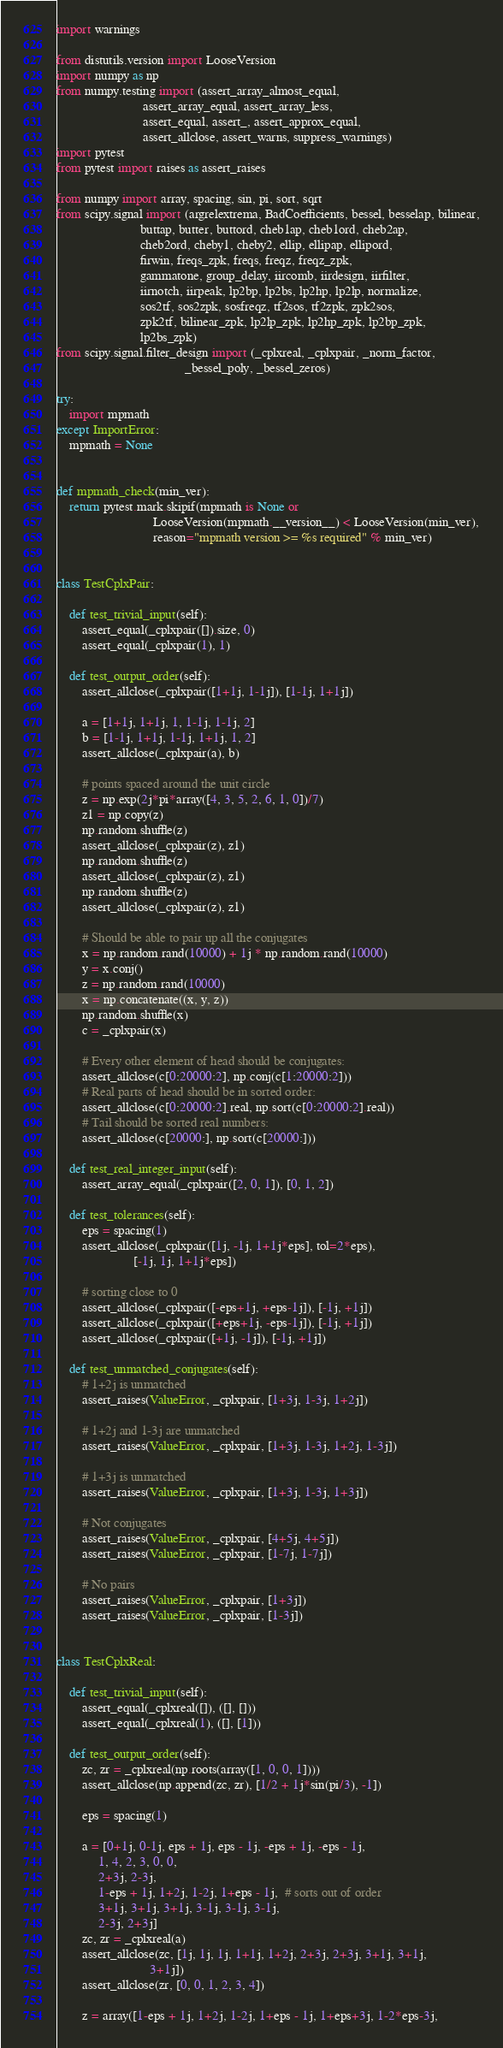<code> <loc_0><loc_0><loc_500><loc_500><_Python_>import warnings

from distutils.version import LooseVersion
import numpy as np
from numpy.testing import (assert_array_almost_equal,
                           assert_array_equal, assert_array_less,
                           assert_equal, assert_, assert_approx_equal,
                           assert_allclose, assert_warns, suppress_warnings)
import pytest
from pytest import raises as assert_raises

from numpy import array, spacing, sin, pi, sort, sqrt
from scipy.signal import (argrelextrema, BadCoefficients, bessel, besselap, bilinear,
                          buttap, butter, buttord, cheb1ap, cheb1ord, cheb2ap,
                          cheb2ord, cheby1, cheby2, ellip, ellipap, ellipord,
                          firwin, freqs_zpk, freqs, freqz, freqz_zpk,
                          gammatone, group_delay, iircomb, iirdesign, iirfilter, 
                          iirnotch, iirpeak, lp2bp, lp2bs, lp2hp, lp2lp, normalize, 
                          sos2tf, sos2zpk, sosfreqz, tf2sos, tf2zpk, zpk2sos, 
                          zpk2tf, bilinear_zpk, lp2lp_zpk, lp2hp_zpk, lp2bp_zpk,
                          lp2bs_zpk)
from scipy.signal.filter_design import (_cplxreal, _cplxpair, _norm_factor,
                                        _bessel_poly, _bessel_zeros)

try:
    import mpmath
except ImportError:
    mpmath = None


def mpmath_check(min_ver):
    return pytest.mark.skipif(mpmath is None or
                              LooseVersion(mpmath.__version__) < LooseVersion(min_ver),
                              reason="mpmath version >= %s required" % min_ver)


class TestCplxPair:

    def test_trivial_input(self):
        assert_equal(_cplxpair([]).size, 0)
        assert_equal(_cplxpair(1), 1)

    def test_output_order(self):
        assert_allclose(_cplxpair([1+1j, 1-1j]), [1-1j, 1+1j])

        a = [1+1j, 1+1j, 1, 1-1j, 1-1j, 2]
        b = [1-1j, 1+1j, 1-1j, 1+1j, 1, 2]
        assert_allclose(_cplxpair(a), b)

        # points spaced around the unit circle
        z = np.exp(2j*pi*array([4, 3, 5, 2, 6, 1, 0])/7)
        z1 = np.copy(z)
        np.random.shuffle(z)
        assert_allclose(_cplxpair(z), z1)
        np.random.shuffle(z)
        assert_allclose(_cplxpair(z), z1)
        np.random.shuffle(z)
        assert_allclose(_cplxpair(z), z1)

        # Should be able to pair up all the conjugates
        x = np.random.rand(10000) + 1j * np.random.rand(10000)
        y = x.conj()
        z = np.random.rand(10000)
        x = np.concatenate((x, y, z))
        np.random.shuffle(x)
        c = _cplxpair(x)

        # Every other element of head should be conjugates:
        assert_allclose(c[0:20000:2], np.conj(c[1:20000:2]))
        # Real parts of head should be in sorted order:
        assert_allclose(c[0:20000:2].real, np.sort(c[0:20000:2].real))
        # Tail should be sorted real numbers:
        assert_allclose(c[20000:], np.sort(c[20000:]))

    def test_real_integer_input(self):
        assert_array_equal(_cplxpair([2, 0, 1]), [0, 1, 2])

    def test_tolerances(self):
        eps = spacing(1)
        assert_allclose(_cplxpair([1j, -1j, 1+1j*eps], tol=2*eps),
                        [-1j, 1j, 1+1j*eps])

        # sorting close to 0
        assert_allclose(_cplxpair([-eps+1j, +eps-1j]), [-1j, +1j])
        assert_allclose(_cplxpair([+eps+1j, -eps-1j]), [-1j, +1j])
        assert_allclose(_cplxpair([+1j, -1j]), [-1j, +1j])

    def test_unmatched_conjugates(self):
        # 1+2j is unmatched
        assert_raises(ValueError, _cplxpair, [1+3j, 1-3j, 1+2j])

        # 1+2j and 1-3j are unmatched
        assert_raises(ValueError, _cplxpair, [1+3j, 1-3j, 1+2j, 1-3j])

        # 1+3j is unmatched
        assert_raises(ValueError, _cplxpair, [1+3j, 1-3j, 1+3j])

        # Not conjugates
        assert_raises(ValueError, _cplxpair, [4+5j, 4+5j])
        assert_raises(ValueError, _cplxpair, [1-7j, 1-7j])

        # No pairs
        assert_raises(ValueError, _cplxpair, [1+3j])
        assert_raises(ValueError, _cplxpair, [1-3j])


class TestCplxReal:

    def test_trivial_input(self):
        assert_equal(_cplxreal([]), ([], []))
        assert_equal(_cplxreal(1), ([], [1]))

    def test_output_order(self):
        zc, zr = _cplxreal(np.roots(array([1, 0, 0, 1])))
        assert_allclose(np.append(zc, zr), [1/2 + 1j*sin(pi/3), -1])

        eps = spacing(1)

        a = [0+1j, 0-1j, eps + 1j, eps - 1j, -eps + 1j, -eps - 1j,
             1, 4, 2, 3, 0, 0,
             2+3j, 2-3j,
             1-eps + 1j, 1+2j, 1-2j, 1+eps - 1j,  # sorts out of order
             3+1j, 3+1j, 3+1j, 3-1j, 3-1j, 3-1j,
             2-3j, 2+3j]
        zc, zr = _cplxreal(a)
        assert_allclose(zc, [1j, 1j, 1j, 1+1j, 1+2j, 2+3j, 2+3j, 3+1j, 3+1j,
                             3+1j])
        assert_allclose(zr, [0, 0, 1, 2, 3, 4])

        z = array([1-eps + 1j, 1+2j, 1-2j, 1+eps - 1j, 1+eps+3j, 1-2*eps-3j,</code> 